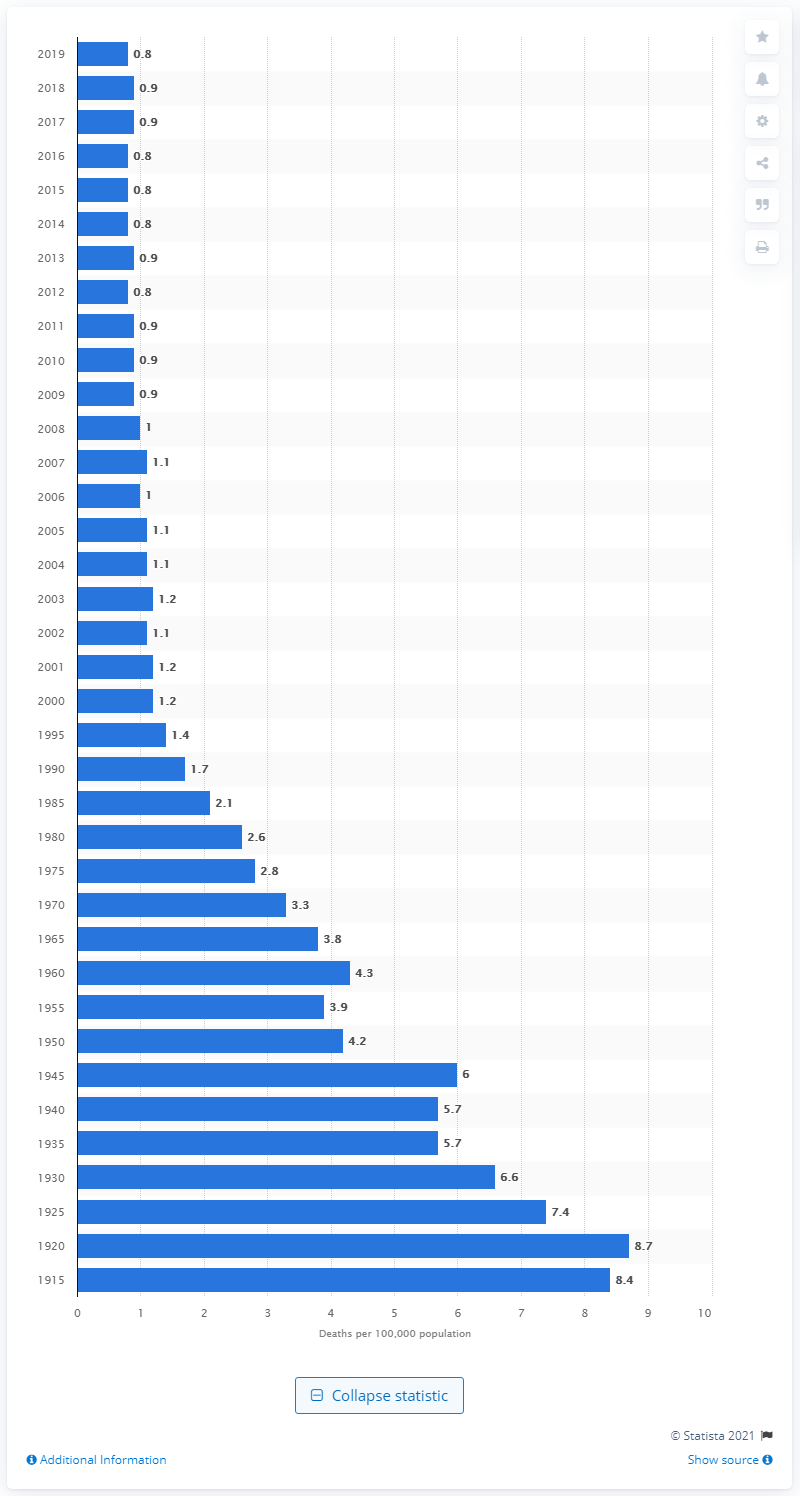Draw attention to some important aspects in this diagram. In 1920, the highest rate of deaths due to fire, flames, or smoke in the United States was 8.7 deaths per million population. 